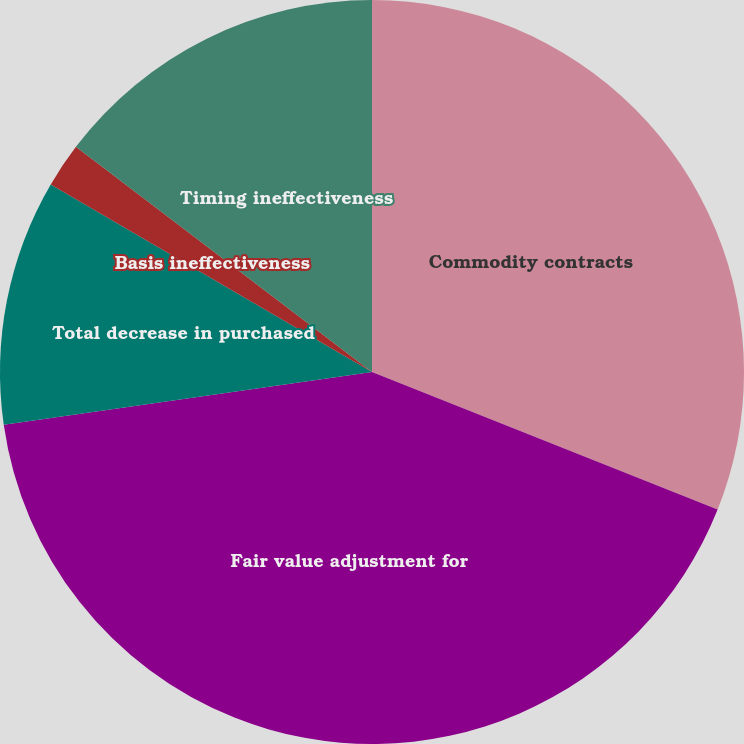Convert chart to OTSL. <chart><loc_0><loc_0><loc_500><loc_500><pie_chart><fcel>Commodity contracts<fcel>Fair value adjustment for<fcel>Total decrease in purchased<fcel>Basis ineffectiveness<fcel>Timing ineffectiveness<nl><fcel>31.03%<fcel>41.71%<fcel>10.67%<fcel>1.94%<fcel>14.65%<nl></chart> 